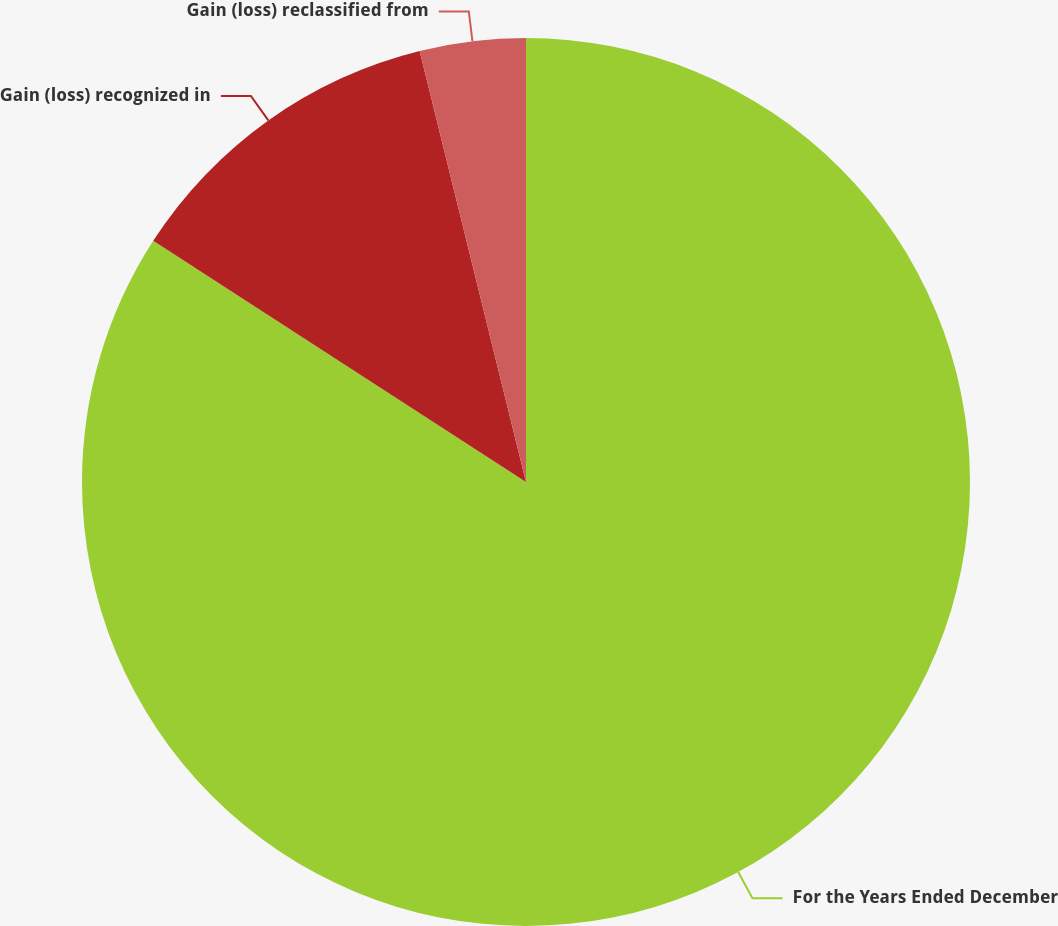Convert chart to OTSL. <chart><loc_0><loc_0><loc_500><loc_500><pie_chart><fcel>For the Years Ended December<fcel>Gain (loss) recognized in<fcel>Gain (loss) reclassified from<nl><fcel>84.14%<fcel>12.01%<fcel>3.85%<nl></chart> 